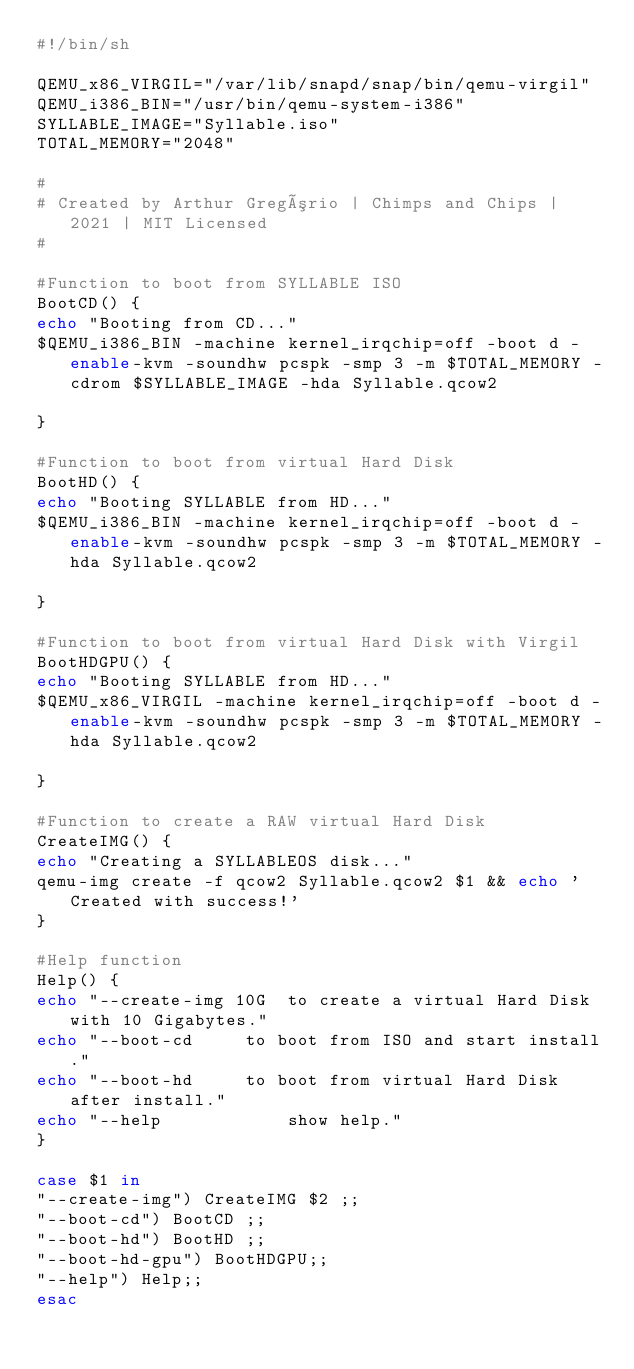Convert code to text. <code><loc_0><loc_0><loc_500><loc_500><_Bash_>#!/bin/sh

QEMU_x86_VIRGIL="/var/lib/snapd/snap/bin/qemu-virgil"
QEMU_i386_BIN="/usr/bin/qemu-system-i386"
SYLLABLE_IMAGE="Syllable.iso"
TOTAL_MEMORY="2048"

#
# Created by Arthur Gregório | Chimps and Chips | 2021 | MIT Licensed
#

#Function to boot from SYLLABLE ISO
BootCD() {
echo "Booting from CD..."
$QEMU_i386_BIN -machine kernel_irqchip=off -boot d -enable-kvm -soundhw pcspk -smp 3 -m $TOTAL_MEMORY -cdrom $SYLLABLE_IMAGE -hda Syllable.qcow2

}

#Function to boot from virtual Hard Disk
BootHD() {
echo "Booting SYLLABLE from HD..."
$QEMU_i386_BIN -machine kernel_irqchip=off -boot d -enable-kvm -soundhw pcspk -smp 3 -m $TOTAL_MEMORY -hda Syllable.qcow2

}

#Function to boot from virtual Hard Disk with Virgil
BootHDGPU() {
echo "Booting SYLLABLE from HD..."
$QEMU_x86_VIRGIL -machine kernel_irqchip=off -boot d -enable-kvm -soundhw pcspk -smp 3 -m $TOTAL_MEMORY -hda Syllable.qcow2

}

#Function to create a RAW virtual Hard Disk
CreateIMG() {
echo "Creating a SYLLABLEOS disk..."
qemu-img create -f qcow2 Syllable.qcow2 $1 && echo 'Created with success!'
}

#Help function
Help() {
echo "--create-img 10G	to create a virtual Hard Disk with 10 Gigabytes."
echo "--boot-cd		to boot from ISO and start install."
echo "--boot-hd		to boot from virtual Hard Disk after install."
echo "--help			show help."
}

case $1 in
"--create-img") CreateIMG $2 ;;
"--boot-cd") BootCD ;;
"--boot-hd") BootHD ;;
"--boot-hd-gpu") BootHDGPU;;
"--help") Help;;
esac
</code> 